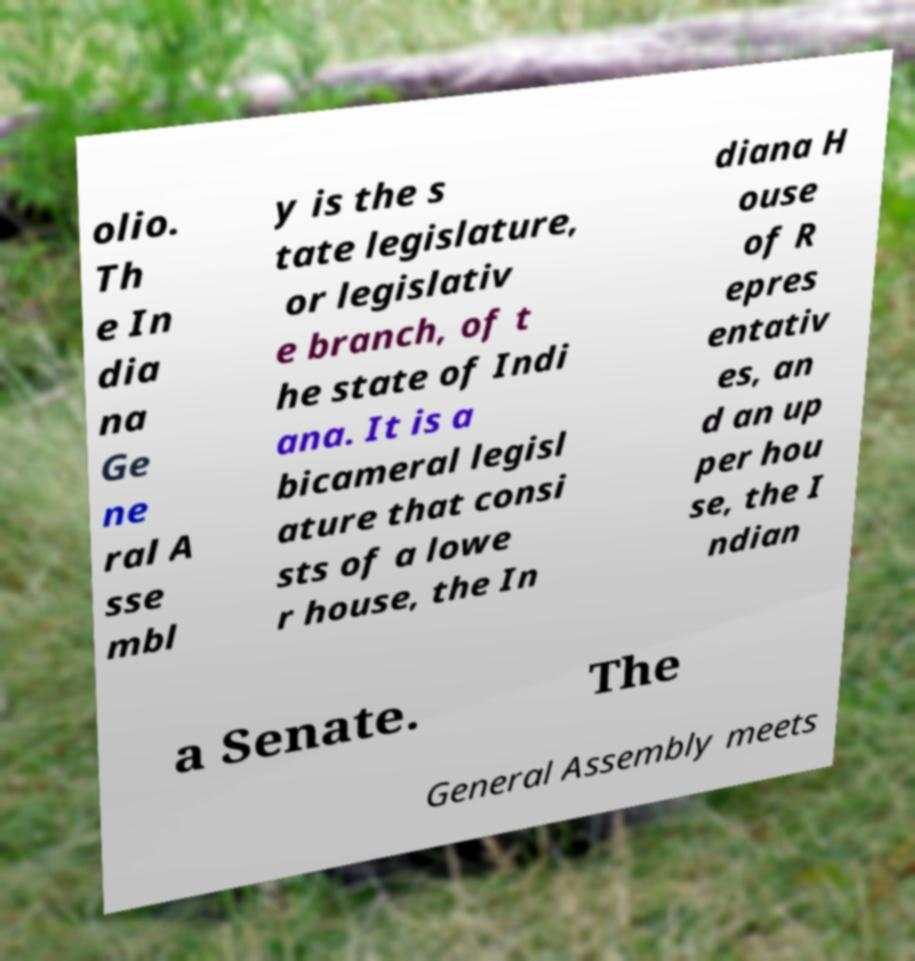Please identify and transcribe the text found in this image. olio. Th e In dia na Ge ne ral A sse mbl y is the s tate legislature, or legislativ e branch, of t he state of Indi ana. It is a bicameral legisl ature that consi sts of a lowe r house, the In diana H ouse of R epres entativ es, an d an up per hou se, the I ndian a Senate. The General Assembly meets 